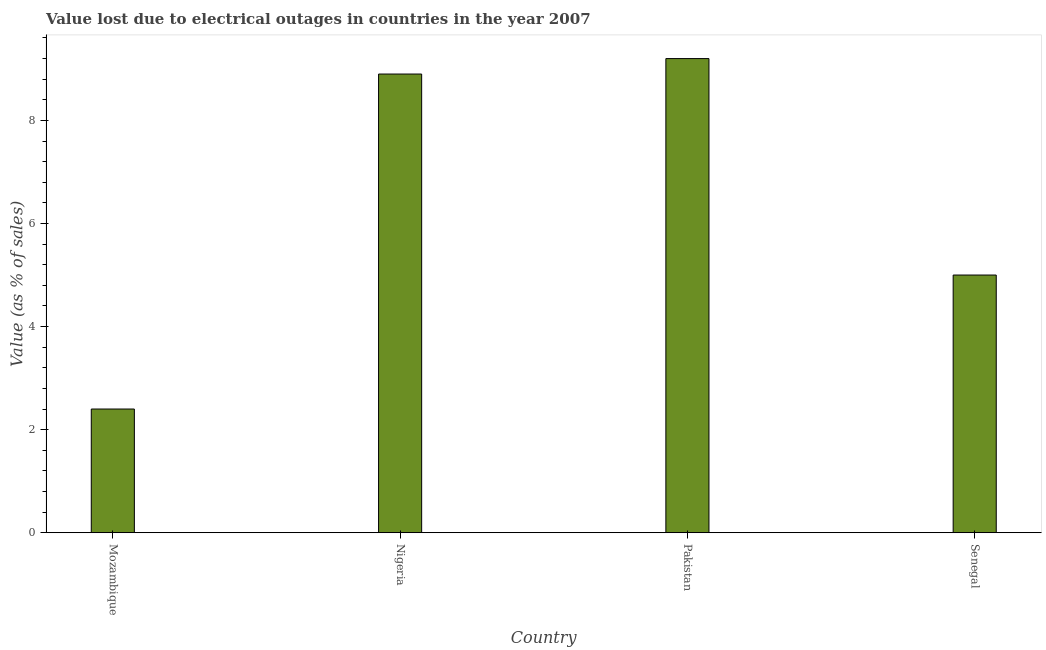Does the graph contain grids?
Your answer should be compact. No. What is the title of the graph?
Make the answer very short. Value lost due to electrical outages in countries in the year 2007. What is the label or title of the Y-axis?
Provide a short and direct response. Value (as % of sales). Across all countries, what is the minimum value lost due to electrical outages?
Offer a terse response. 2.4. In which country was the value lost due to electrical outages minimum?
Keep it short and to the point. Mozambique. What is the sum of the value lost due to electrical outages?
Keep it short and to the point. 25.5. What is the average value lost due to electrical outages per country?
Keep it short and to the point. 6.38. What is the median value lost due to electrical outages?
Offer a terse response. 6.95. What is the ratio of the value lost due to electrical outages in Nigeria to that in Senegal?
Provide a succinct answer. 1.78. Is the value lost due to electrical outages in Pakistan less than that in Senegal?
Provide a short and direct response. No. Is the difference between the value lost due to electrical outages in Mozambique and Pakistan greater than the difference between any two countries?
Provide a short and direct response. Yes. What is the difference between the highest and the lowest value lost due to electrical outages?
Provide a short and direct response. 6.8. In how many countries, is the value lost due to electrical outages greater than the average value lost due to electrical outages taken over all countries?
Your response must be concise. 2. How many bars are there?
Offer a very short reply. 4. What is the Value (as % of sales) of Nigeria?
Provide a short and direct response. 8.9. What is the Value (as % of sales) in Senegal?
Provide a succinct answer. 5. What is the difference between the Value (as % of sales) in Mozambique and Nigeria?
Your answer should be very brief. -6.5. What is the difference between the Value (as % of sales) in Mozambique and Pakistan?
Offer a terse response. -6.8. What is the ratio of the Value (as % of sales) in Mozambique to that in Nigeria?
Offer a very short reply. 0.27. What is the ratio of the Value (as % of sales) in Mozambique to that in Pakistan?
Give a very brief answer. 0.26. What is the ratio of the Value (as % of sales) in Mozambique to that in Senegal?
Make the answer very short. 0.48. What is the ratio of the Value (as % of sales) in Nigeria to that in Pakistan?
Ensure brevity in your answer.  0.97. What is the ratio of the Value (as % of sales) in Nigeria to that in Senegal?
Offer a very short reply. 1.78. What is the ratio of the Value (as % of sales) in Pakistan to that in Senegal?
Your answer should be compact. 1.84. 